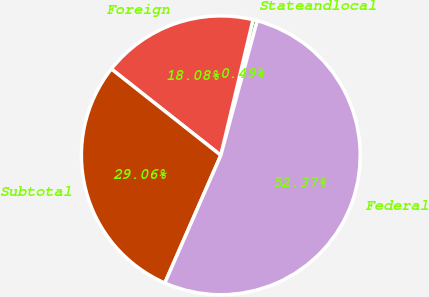Convert chart. <chart><loc_0><loc_0><loc_500><loc_500><pie_chart><fcel>Stateandlocal<fcel>Foreign<fcel>Subtotal<fcel>Federal<nl><fcel>0.49%<fcel>18.08%<fcel>29.06%<fcel>52.38%<nl></chart> 